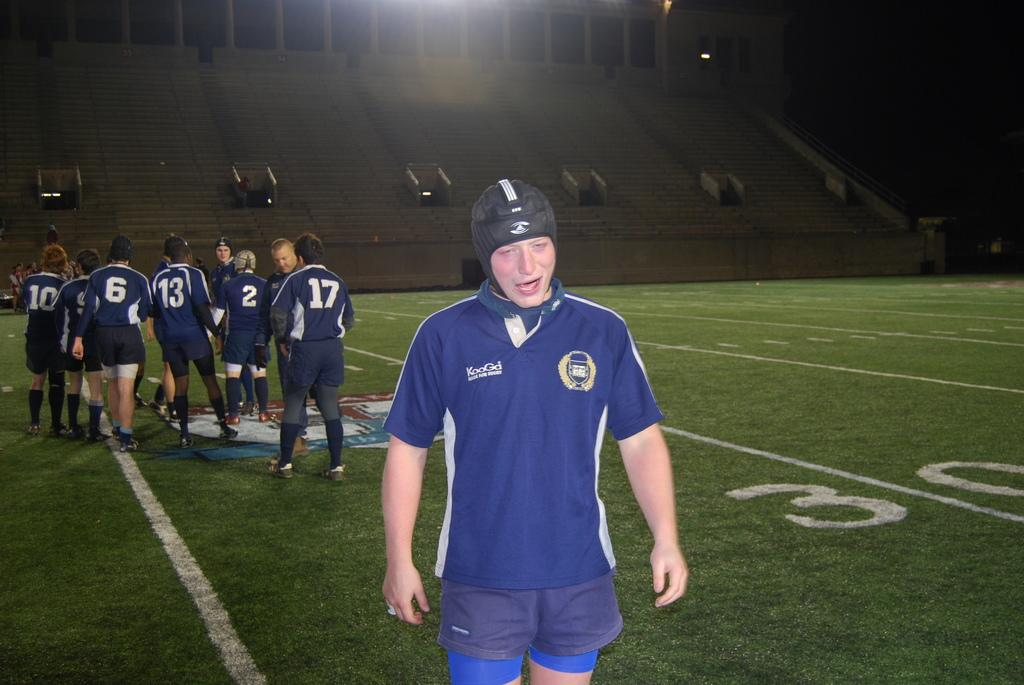<image>
Give a short and clear explanation of the subsequent image. A young man in a KooGa team jersey is walking off a football field, away from his teammates. 